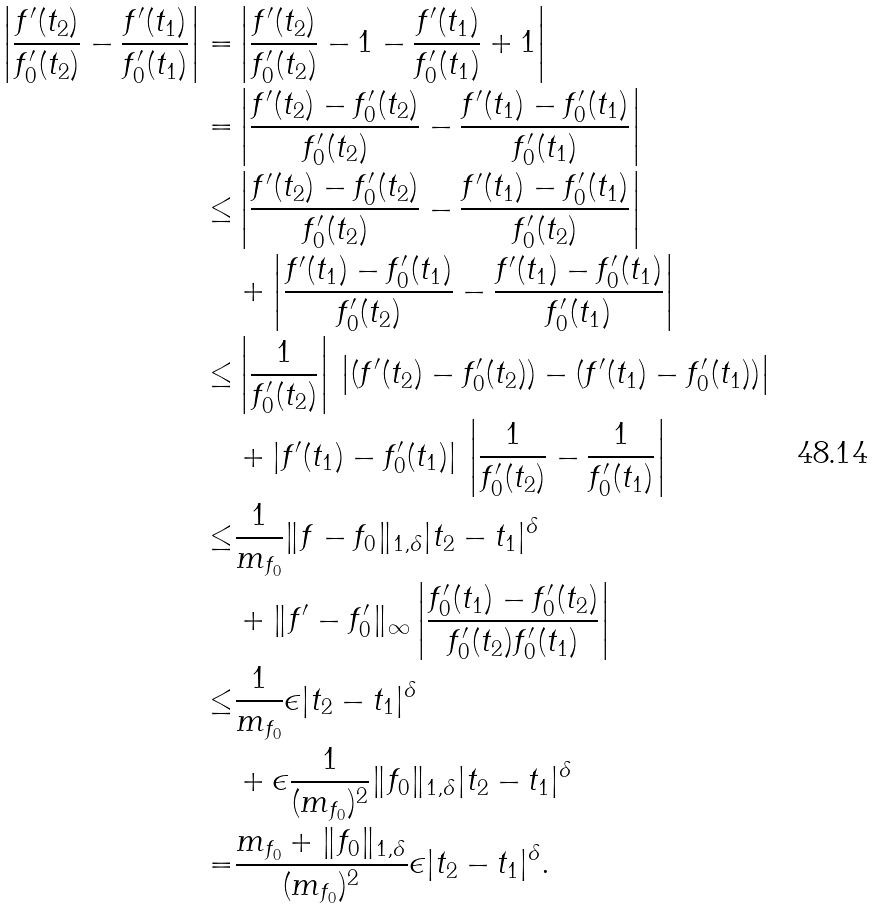<formula> <loc_0><loc_0><loc_500><loc_500>\left | \frac { f ^ { \prime } ( t _ { 2 } ) } { f ^ { \prime } _ { 0 } ( t _ { 2 } ) } - \frac { f ^ { \prime } ( t _ { 1 } ) } { f ^ { \prime } _ { 0 } ( t _ { 1 } ) } \right | = & \left | \frac { f ^ { \prime } ( t _ { 2 } ) } { f ^ { \prime } _ { 0 } ( t _ { 2 } ) } - 1 - \frac { f ^ { \prime } ( t _ { 1 } ) } { f ^ { \prime } _ { 0 } ( t _ { 1 } ) } + 1 \right | \\ = & \left | \frac { f ^ { \prime } ( t _ { 2 } ) - f ^ { \prime } _ { 0 } ( t _ { 2 } ) } { f ^ { \prime } _ { 0 } ( t _ { 2 } ) } - \frac { f ^ { \prime } ( t _ { 1 } ) - f ^ { \prime } _ { 0 } ( t _ { 1 } ) } { f ^ { \prime } _ { 0 } ( t _ { 1 } ) } \right | \\ \leq & \left | \frac { f ^ { \prime } ( t _ { 2 } ) - f ^ { \prime } _ { 0 } ( t _ { 2 } ) } { f ^ { \prime } _ { 0 } ( t _ { 2 } ) } - \frac { f ^ { \prime } ( t _ { 1 } ) - f ^ { \prime } _ { 0 } ( t _ { 1 } ) } { f ^ { \prime } _ { 0 } ( t _ { 2 } ) } \right | \\ & + \left | \frac { f ^ { \prime } ( t _ { 1 } ) - f ^ { \prime } _ { 0 } ( t _ { 1 } ) } { f ^ { \prime } _ { 0 } ( t _ { 2 } ) } - \frac { f ^ { \prime } ( t _ { 1 } ) - f ^ { \prime } _ { 0 } ( t _ { 1 } ) } { f ^ { \prime } _ { 0 } ( t _ { 1 } ) } \right | \\ \leq & \left | \frac { 1 } { f ^ { \prime } _ { 0 } ( t _ { 2 } ) } \right | \, \left | ( { f ^ { \prime } ( t _ { 2 } ) - f ^ { \prime } _ { 0 } ( t _ { 2 } ) } ) - ( f ^ { \prime } ( t _ { 1 } ) - f ^ { \prime } _ { 0 } ( t _ { 1 } ) ) \right | \\ & + | f ^ { \prime } ( t _ { 1 } ) - f ^ { \prime } _ { 0 } ( t _ { 1 } ) | \, \left | \frac { 1 } { f ^ { \prime } _ { 0 } ( t _ { 2 } ) } - \frac { 1 } { f ^ { \prime } _ { 0 } ( t _ { 1 } ) } \right | \\ \leq & \frac { 1 } { m _ { f _ { 0 } } } \| f - f _ { 0 } \| _ { 1 , \delta } | t _ { 2 } - t _ { 1 } | ^ { \delta } \\ & + \| f ^ { \prime } - f ^ { \prime } _ { 0 } \| _ { \infty } \left | \frac { f ^ { \prime } _ { 0 } ( t _ { 1 } ) - f ^ { \prime } _ { 0 } ( t _ { 2 } ) } { f ^ { \prime } _ { 0 } ( t _ { 2 } ) f ^ { \prime } _ { 0 } ( t _ { 1 } ) } \right | \\ \leq & \frac { 1 } { m _ { f _ { 0 } } } \epsilon | t _ { 2 } - t _ { 1 } | ^ { \delta } \\ & + \epsilon \frac { 1 } { ( m _ { f _ { 0 } } ) ^ { 2 } } \| f _ { 0 } \| _ { 1 , \delta } | t _ { 2 } - t _ { 1 } | ^ { \delta } \\ = & \frac { m _ { f _ { 0 } } + \| f _ { 0 } \| _ { 1 , \delta } } { ( m _ { f _ { 0 } } ) ^ { 2 } } \epsilon | t _ { 2 } - t _ { 1 } | ^ { \delta } .</formula> 